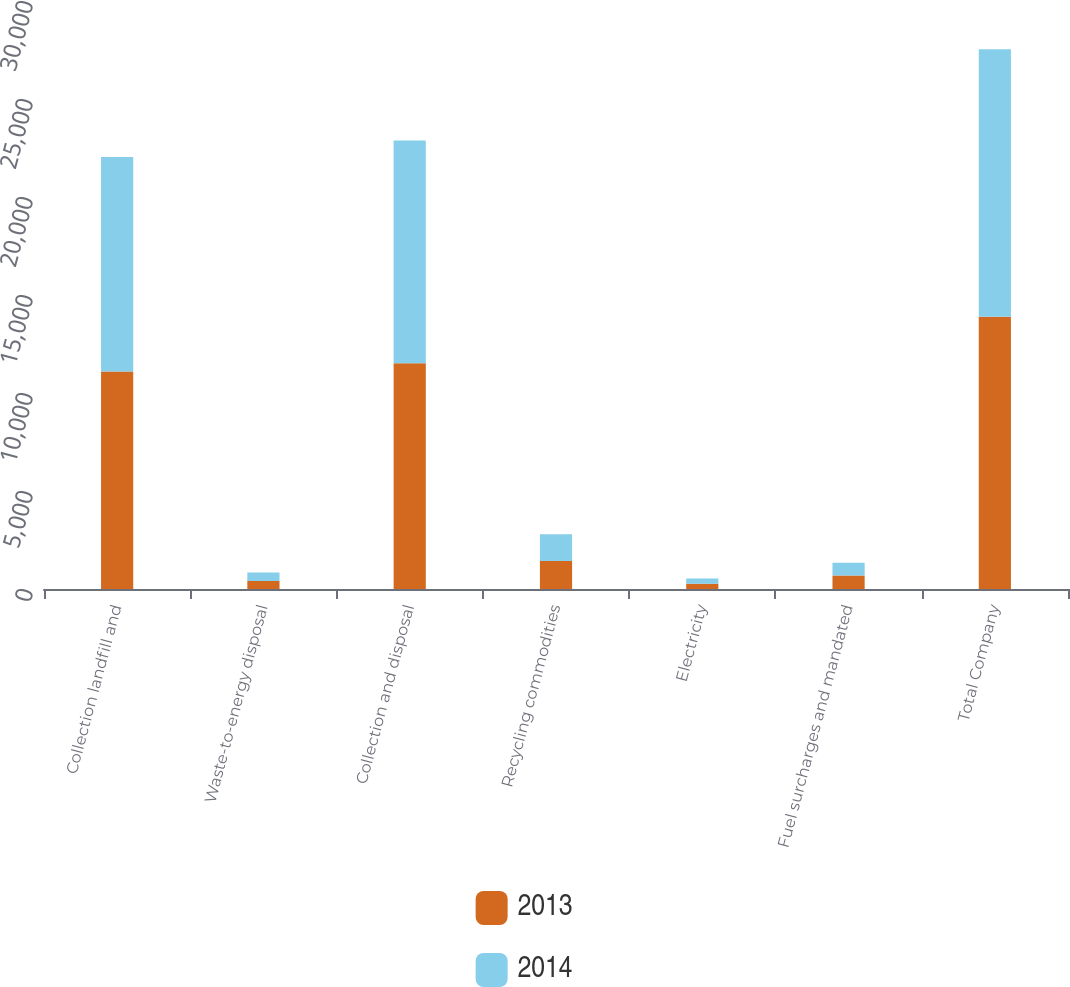Convert chart. <chart><loc_0><loc_0><loc_500><loc_500><stacked_bar_chart><ecel><fcel>Collection landfill and<fcel>Waste-to-energy disposal<fcel>Collection and disposal<fcel>Recycling commodities<fcel>Electricity<fcel>Fuel surcharges and mandated<fcel>Total Company<nl><fcel>2013<fcel>11103<fcel>409<fcel>11512<fcel>1431<fcel>266<fcel>684<fcel>13893<nl><fcel>2014<fcel>10939<fcel>431<fcel>11370<fcel>1357<fcel>266<fcel>650<fcel>13643<nl></chart> 